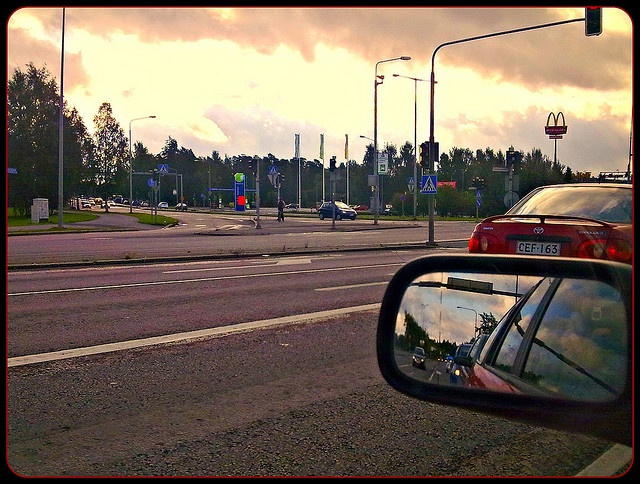Describe the objects in this image and their specific colors. I can see car in black, gray, and blue tones, car in black, maroon, and gray tones, traffic light in black, gray, khaki, and beige tones, car in black, navy, gray, and ivory tones, and traffic light in black, gray, and darkblue tones in this image. 